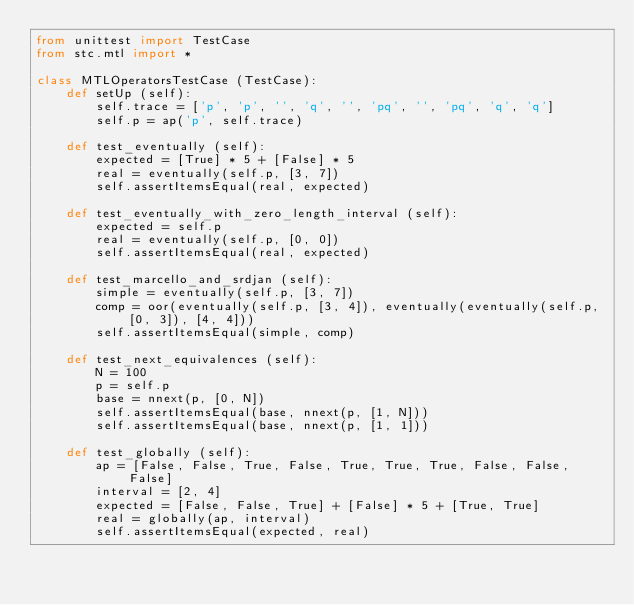Convert code to text. <code><loc_0><loc_0><loc_500><loc_500><_Python_>from unittest import TestCase
from stc.mtl import *

class MTLOperatorsTestCase (TestCase):
    def setUp (self):
        self.trace = ['p', 'p', '', 'q', '', 'pq', '', 'pq', 'q', 'q']
        self.p = ap('p', self.trace)

    def test_eventually (self):
        expected = [True] * 5 + [False] * 5
        real = eventually(self.p, [3, 7])
        self.assertItemsEqual(real, expected)

    def test_eventually_with_zero_length_interval (self):
        expected = self.p
        real = eventually(self.p, [0, 0])
        self.assertItemsEqual(real, expected)

    def test_marcello_and_srdjan (self):
        simple = eventually(self.p, [3, 7])
        comp = oor(eventually(self.p, [3, 4]), eventually(eventually(self.p, [0, 3]), [4, 4]))
        self.assertItemsEqual(simple, comp)

    def test_next_equivalences (self):
        N = 100
        p = self.p
        base = nnext(p, [0, N])
        self.assertItemsEqual(base, nnext(p, [1, N]))
        self.assertItemsEqual(base, nnext(p, [1, 1]))

    def test_globally (self):
        ap = [False, False, True, False, True, True, True, False, False, False]
        interval = [2, 4]
        expected = [False, False, True] + [False] * 5 + [True, True]
        real = globally(ap, interval)
        self.assertItemsEqual(expected, real)

</code> 